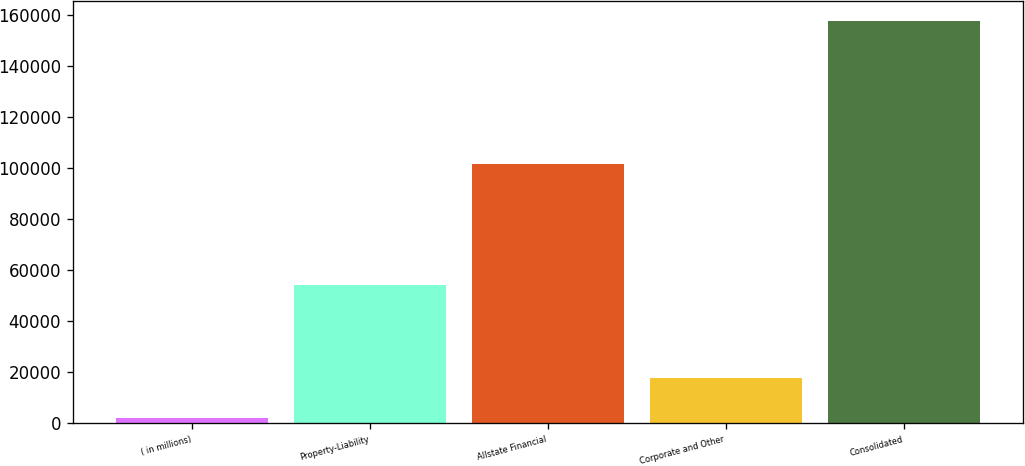Convert chart. <chart><loc_0><loc_0><loc_500><loc_500><bar_chart><fcel>( in millions)<fcel>Property-Liability<fcel>Allstate Financial<fcel>Corporate and Other<fcel>Consolidated<nl><fcel>2006<fcel>53952<fcel>101317<fcel>17560.8<fcel>157554<nl></chart> 